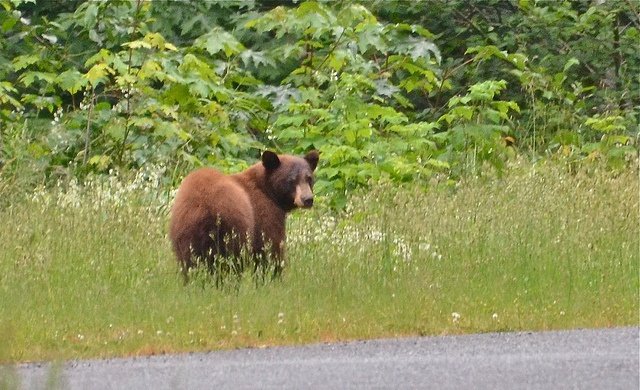Describe the objects in this image and their specific colors. I can see a bear in olive, brown, black, maroon, and gray tones in this image. 